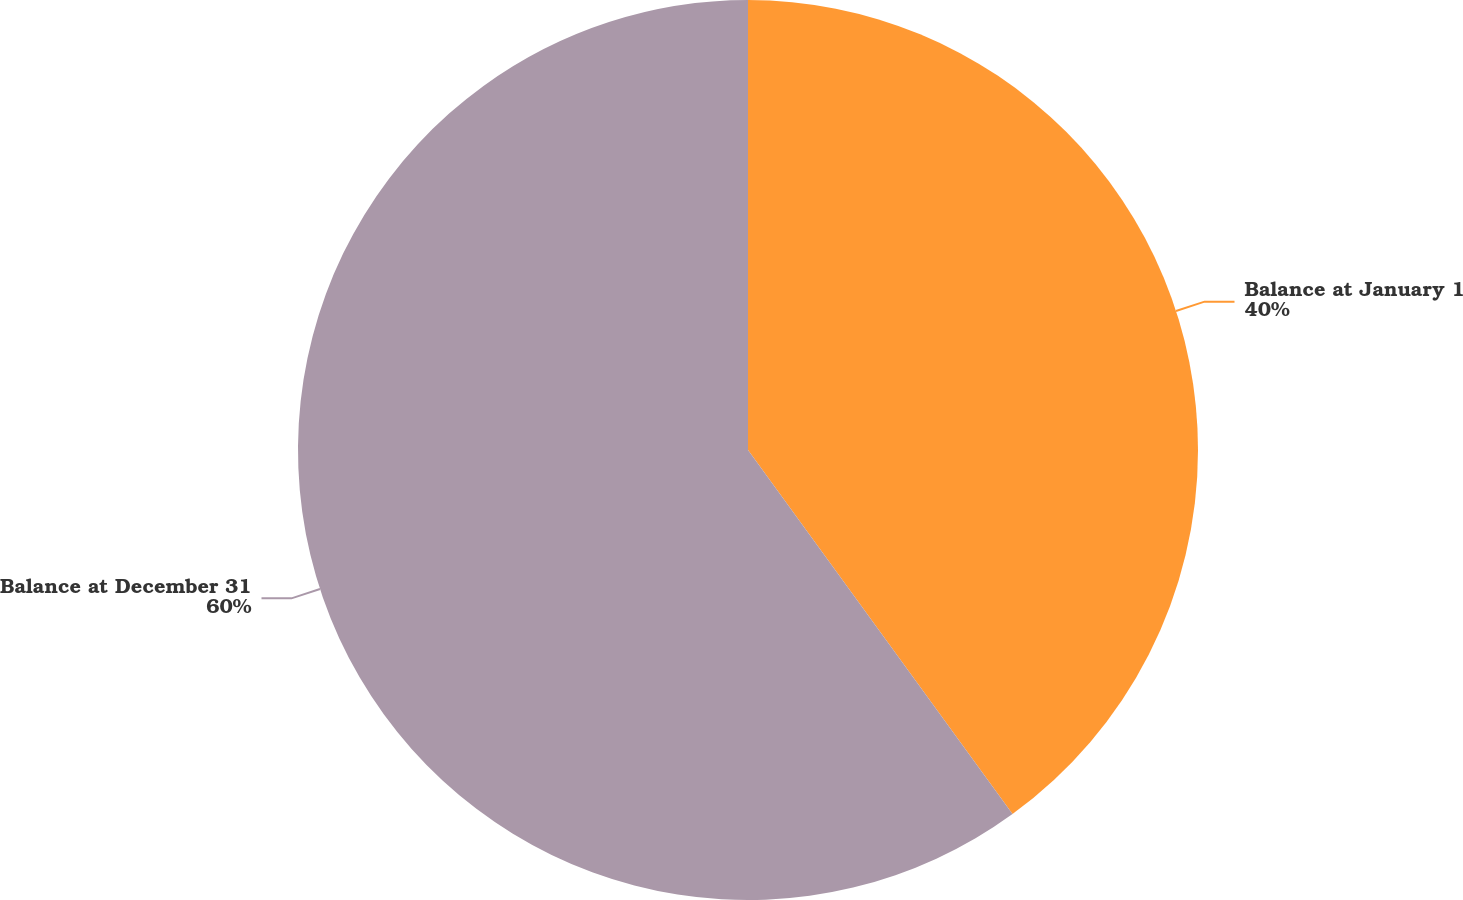Convert chart. <chart><loc_0><loc_0><loc_500><loc_500><pie_chart><fcel>Balance at January 1<fcel>Balance at December 31<nl><fcel>40.0%<fcel>60.0%<nl></chart> 